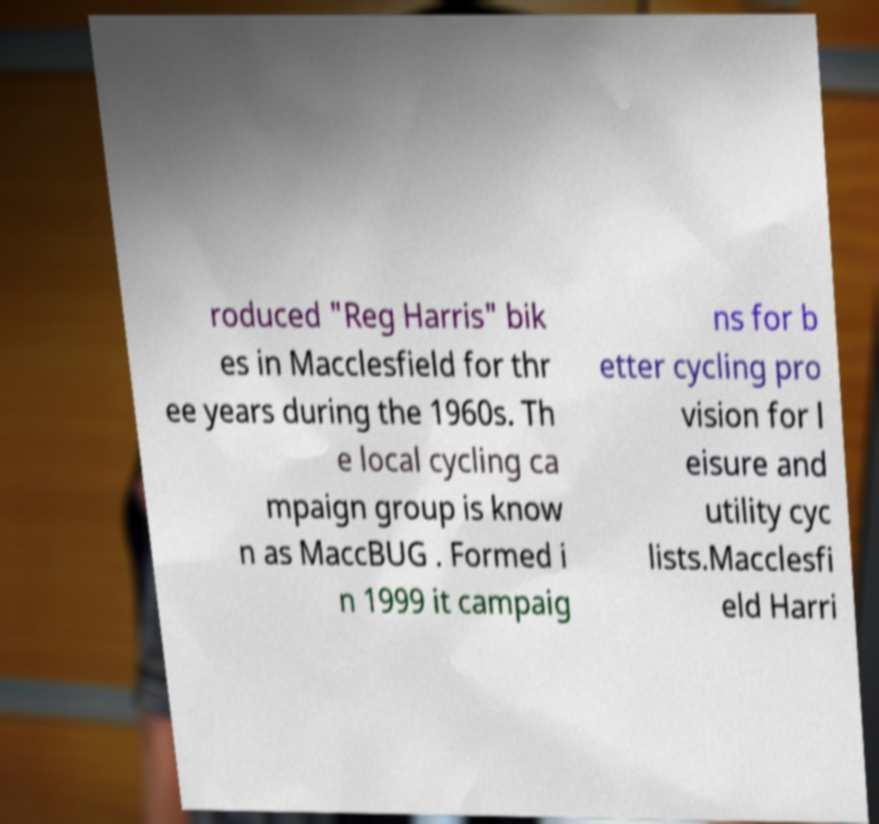There's text embedded in this image that I need extracted. Can you transcribe it verbatim? roduced "Reg Harris" bik es in Macclesfield for thr ee years during the 1960s. Th e local cycling ca mpaign group is know n as MaccBUG . Formed i n 1999 it campaig ns for b etter cycling pro vision for l eisure and utility cyc lists.Macclesfi eld Harri 